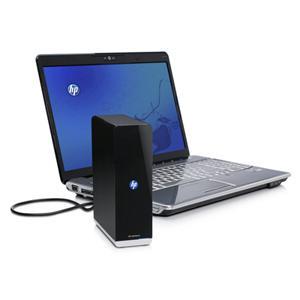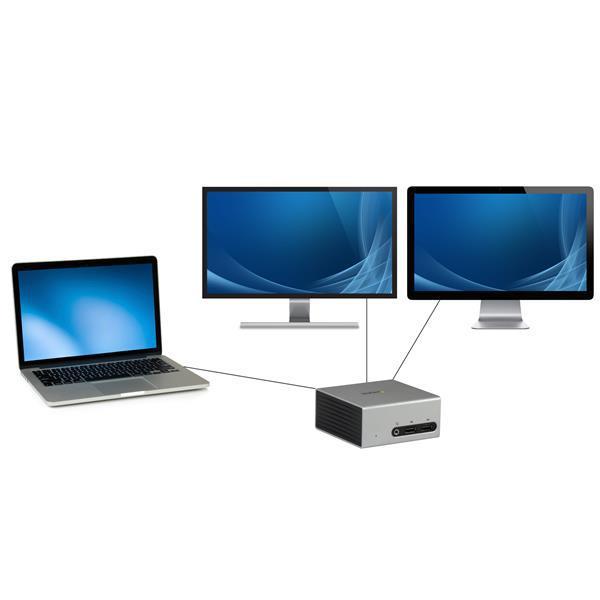The first image is the image on the left, the second image is the image on the right. Evaluate the accuracy of this statement regarding the images: "There is exactly one laptop in the left image.". Is it true? Answer yes or no. Yes. The first image is the image on the left, the second image is the image on the right. Analyze the images presented: Is the assertion "An image includes side-by-side monitors with blue curving lines on the screen, and a smaller laptop." valid? Answer yes or no. Yes. 